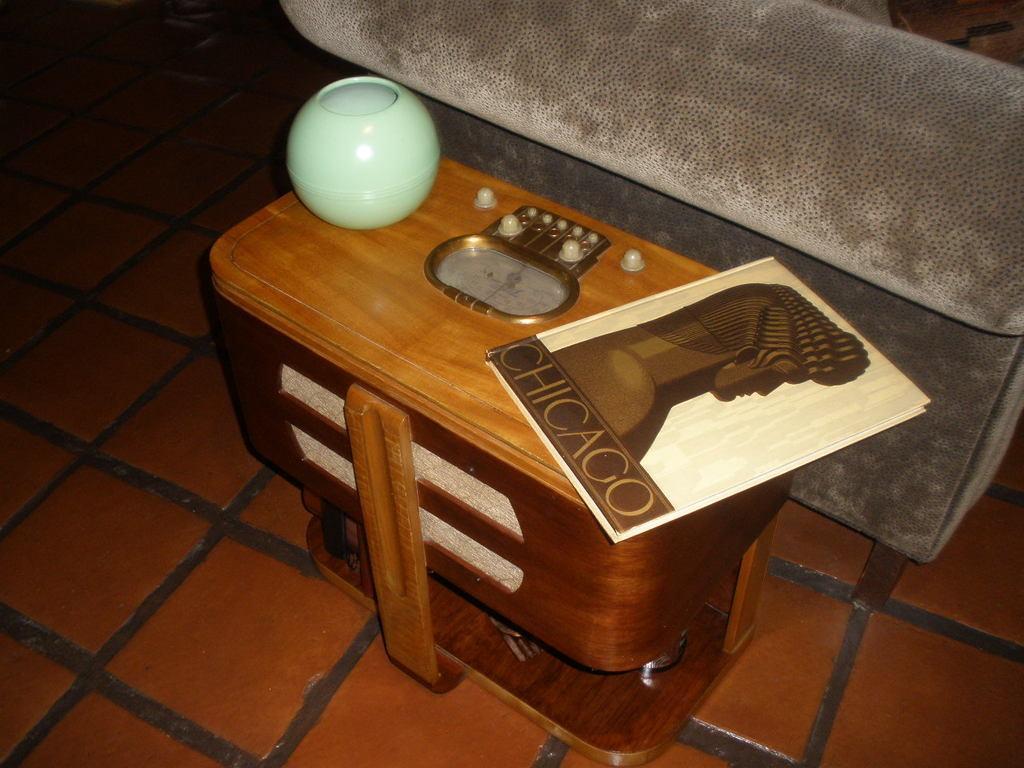Could you give a brief overview of what you see in this image? In the center of the image we can see a table and some objects, book are present. In the background of the image floor is there. 